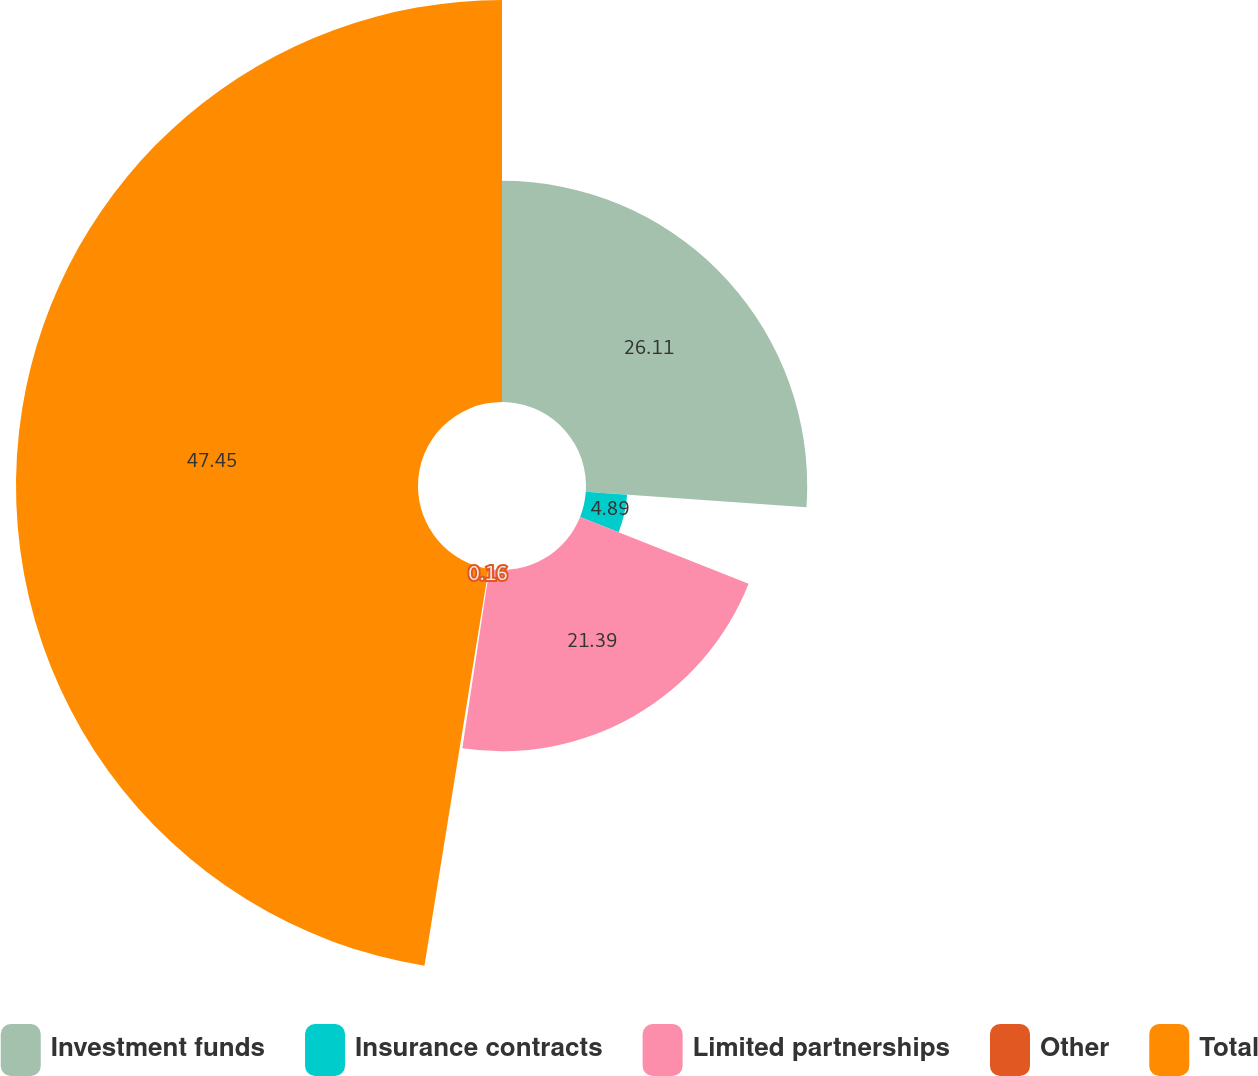<chart> <loc_0><loc_0><loc_500><loc_500><pie_chart><fcel>Investment funds<fcel>Insurance contracts<fcel>Limited partnerships<fcel>Other<fcel>Total<nl><fcel>26.11%<fcel>4.89%<fcel>21.39%<fcel>0.16%<fcel>47.45%<nl></chart> 